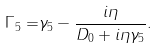Convert formula to latex. <formula><loc_0><loc_0><loc_500><loc_500>\Gamma _ { 5 } = & \gamma _ { 5 } - \frac { i \eta } { D _ { 0 } + i \eta \gamma _ { 5 } } .</formula> 